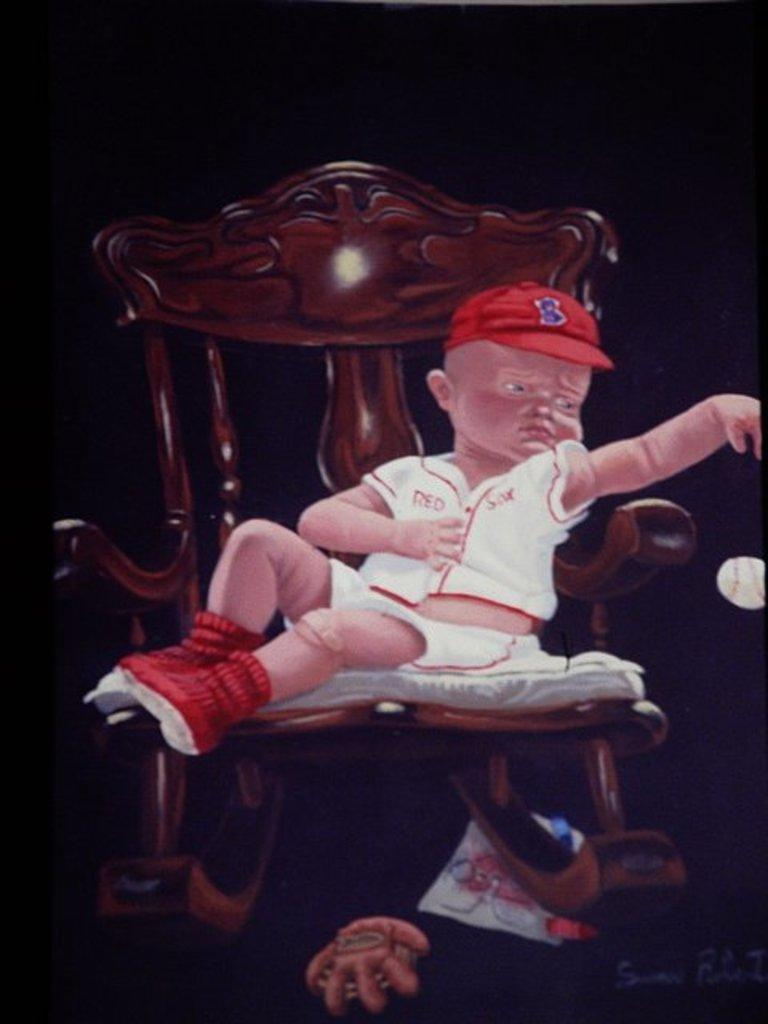What is the main subject of the image? There is a boy sitting on a chair in the image. Can you describe any objects present in the image? There are objects in the image, but their specific details are not mentioned in the provided facts. What is the color or lighting of the background in the image? The background of the image is dark. What type of steel is used to make the boy's legs in the image? The boy is not made of steel, and there is no indication that his legs are made of steel in the image. How many matches can be seen in the image? There are no matches present in the image. 